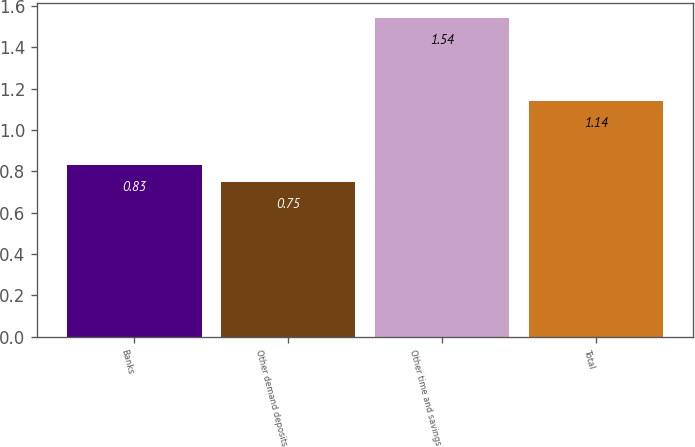<chart> <loc_0><loc_0><loc_500><loc_500><bar_chart><fcel>Banks<fcel>Other demand deposits<fcel>Other time and savings<fcel>Total<nl><fcel>0.83<fcel>0.75<fcel>1.54<fcel>1.14<nl></chart> 